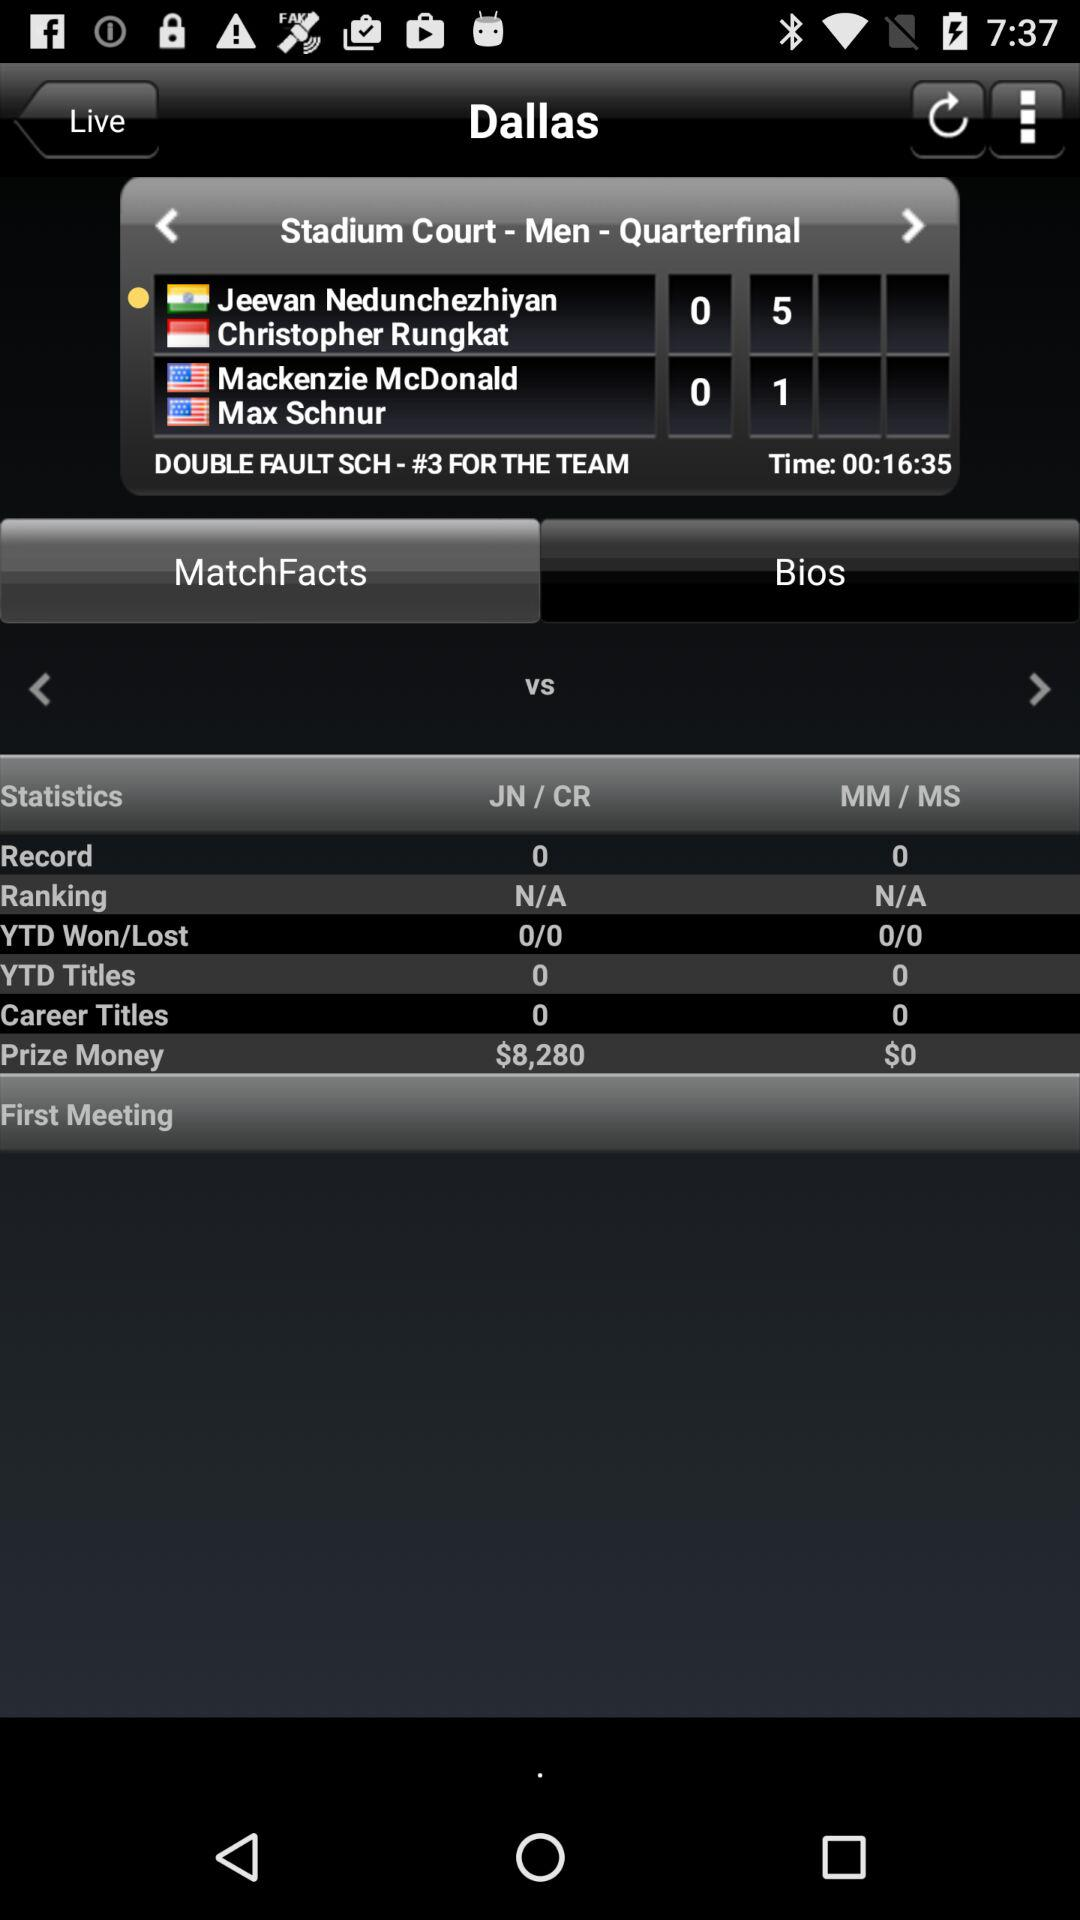What is the sum of Jeevan Nedunchezhiyan's and Mackenzie McDonald's prize money?
Answer the question using a single word or phrase. $8,280 